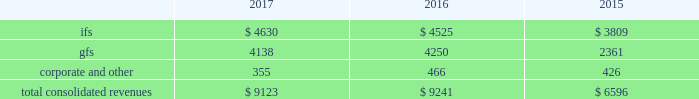2022 expand client relationships - the overall market we serve continues to gravitate beyond single-application purchases to multi-solution partnerships .
As the market dynamics shift , we expect our clients and prospects to rely more on our multidimensional service offerings .
Our leveraged solutions and processing expertise can produce meaningful value and cost savings for our clients through more efficient operating processes , improved service quality and convenience for our clients' customers .
2022 build global diversification - we continue to deploy resources in global markets where we expect to achieve meaningful scale .
Revenues by segment the table below summarizes our revenues by reporting segment ( in millions ) : .
Integrated financial solutions ( "ifs" ) the ifs segment is focused primarily on serving north american regional and community bank and savings institutions for transaction and account processing , payment solutions , channel solutions , digital channels , fraud , risk management and compliance solutions , lending and wealth and retirement solutions , and corporate liquidity , capitalizing on the continuing trend to outsource these solutions .
Clients in this segment include regional and community banks , credit unions and commercial lenders , as well as government institutions , merchants and other commercial organizations .
These markets are primarily served through integrated solutions and characterized by multi-year processing contracts that generate highly recurring revenues .
The predictable nature of cash flows generated from this segment provides opportunities for further investments in innovation , integration , information and security , and compliance in a cost-effective manner .
Our solutions in this segment include : 2022 core processing and ancillary applications .
Our core processing software applications are designed to run banking processes for our financial institution clients , including deposit and lending systems , customer management , and other central management systems , serving as the system of record for processed activity .
Our diverse selection of market- focused core systems enables fis to compete effectively in a wide range of markets .
We also offer a number of services that are ancillary to the primary applications listed above , including branch automation , back-office support systems and compliance support .
2022 digital solutions , including internet , mobile and ebanking .
Our comprehensive suite of retail delivery applications enables financial institutions to integrate and streamline customer-facing operations and back-office processes , thereby improving customer interaction across all channels ( e.g. , branch offices , internet , atm , mobile , call centers ) .
Fis' focus on consumer access has driven significant market innovation in this area , with multi-channel and multi-host solutions and a strategy that provides tight integration of services and a seamless customer experience .
Fis is a leader in mobile banking solutions and electronic banking enabling clients to manage banking and payments through the internet , mobile devices , accounting software and telephone .
Our corporate electronic banking solutions provide commercial treasury capabilities including cash management services and multi-bank collection and disbursement services that address the specialized needs of corporate clients .
Fis systems provide full accounting and reconciliation for such transactions , serving also as the system of record. .
What is the growth rate in consolidated revenues from 2016 to 2017? 
Computations: ((9123 - 9241) / 9241)
Answer: -0.01277. 